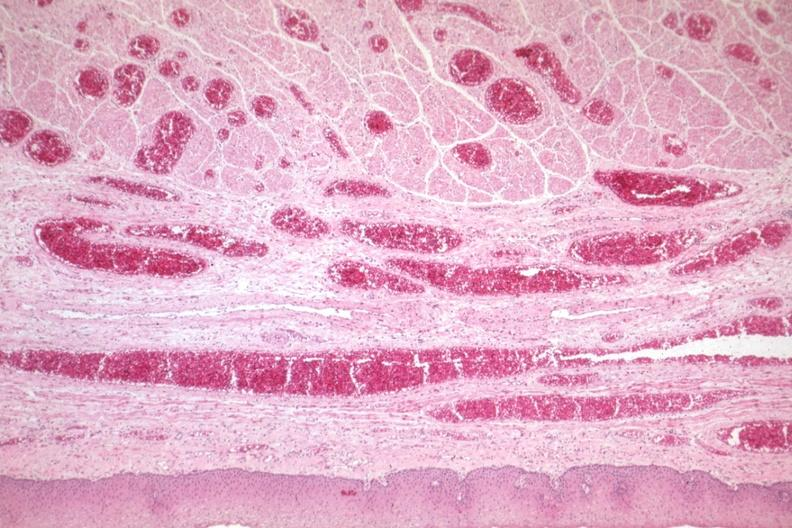s sickle cell disease present?
Answer the question using a single word or phrase. No 